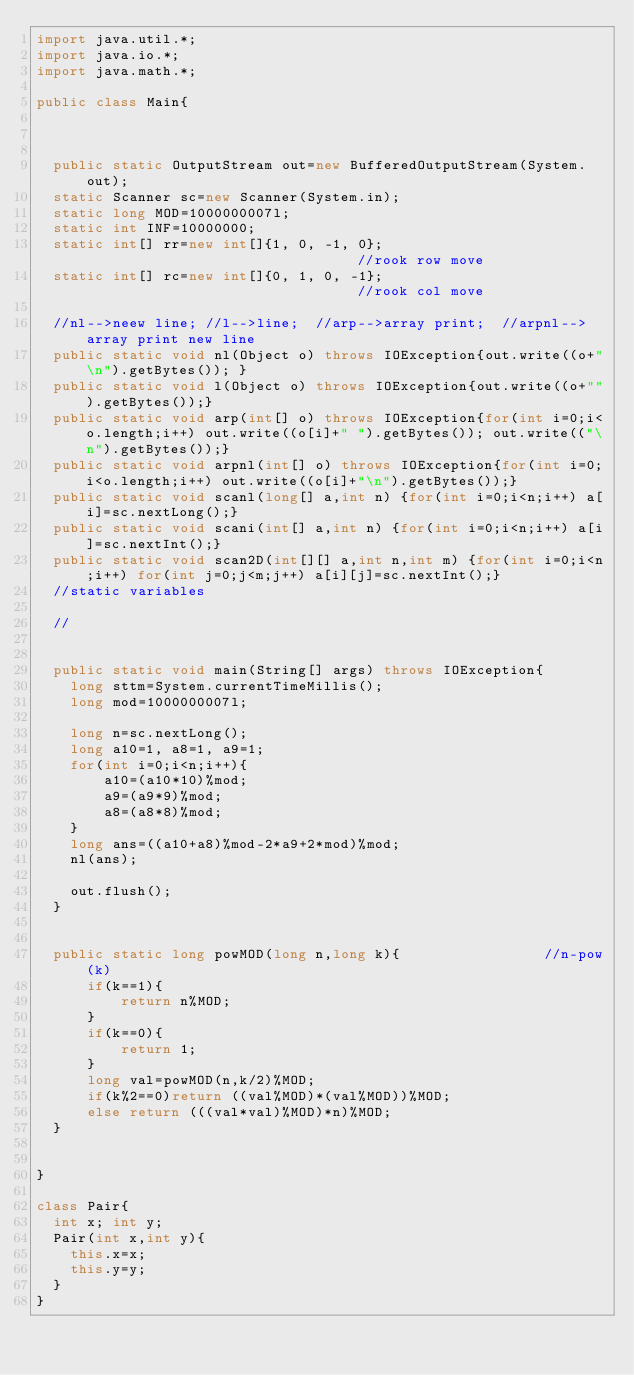Convert code to text. <code><loc_0><loc_0><loc_500><loc_500><_Java_>import java.util.*;
import java.io.*;
import java.math.*;

public class Main{



  public static OutputStream out=new BufferedOutputStream(System.out);
  static Scanner sc=new Scanner(System.in);
  static long MOD=1000000007l;
  static int INF=10000000;
  static int[] rr=new int[]{1, 0, -1, 0};                                 //rook row move
  static int[] rc=new int[]{0, 1, 0, -1};                                 //rook col move

  //nl-->neew line; //l-->line;  //arp-->array print;  //arpnl-->array print new line
  public static void nl(Object o) throws IOException{out.write((o+"\n").getBytes()); }
  public static void l(Object o) throws IOException{out.write((o+"").getBytes());}
  public static void arp(int[] o) throws IOException{for(int i=0;i<o.length;i++) out.write((o[i]+" ").getBytes()); out.write(("\n").getBytes());}
  public static void arpnl(int[] o) throws IOException{for(int i=0;i<o.length;i++) out.write((o[i]+"\n").getBytes());}
  public static void scanl(long[] a,int n) {for(int i=0;i<n;i++) a[i]=sc.nextLong();}
  public static void scani(int[] a,int n) {for(int i=0;i<n;i++) a[i]=sc.nextInt();}
  public static void scan2D(int[][] a,int n,int m) {for(int i=0;i<n;i++) for(int j=0;j<m;j++) a[i][j]=sc.nextInt();}
  //static variables

  //


  public static void main(String[] args) throws IOException{
    long sttm=System.currentTimeMillis();
    long mod=1000000007l;

    long n=sc.nextLong();
    long a10=1, a8=1, a9=1;
    for(int i=0;i<n;i++){
        a10=(a10*10)%mod;
        a9=(a9*9)%mod;
        a8=(a8*8)%mod;
    }
    long ans=((a10+a8)%mod-2*a9+2*mod)%mod;
    nl(ans);

    out.flush();
  }


  public static long powMOD(long n,long k){                 //n-pow(k)
      if(k==1){
          return n%MOD;
      }
      if(k==0){
          return 1;
      }
      long val=powMOD(n,k/2)%MOD;
      if(k%2==0)return ((val%MOD)*(val%MOD))%MOD;
      else return (((val*val)%MOD)*n)%MOD;
  }


}

class Pair{
  int x; int y;
  Pair(int x,int y){
    this.x=x;
    this.y=y;
  }
}
</code> 